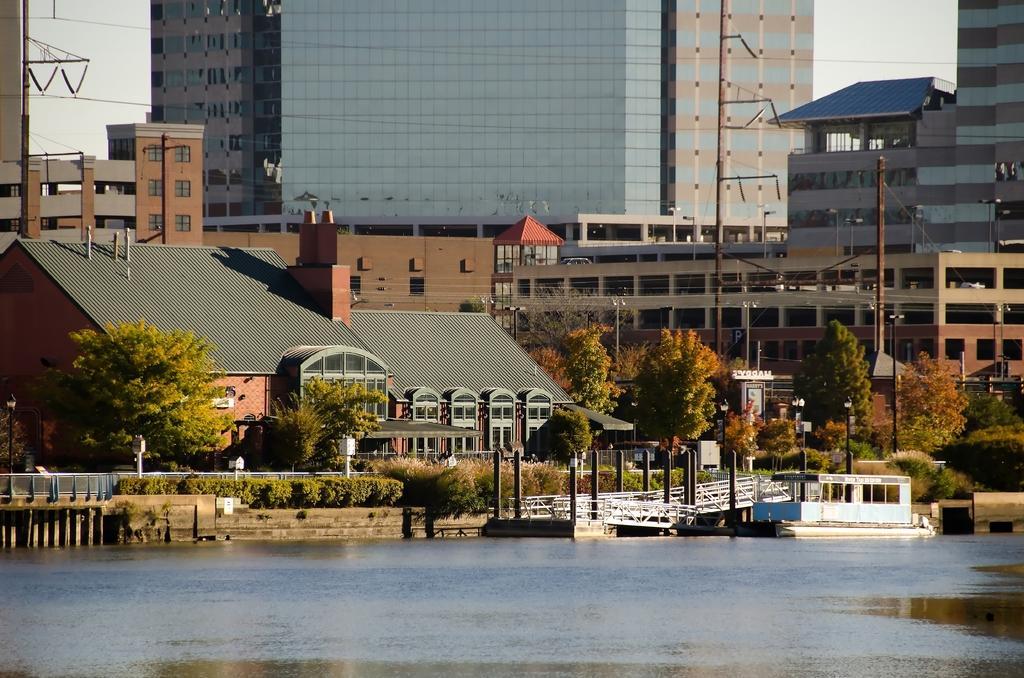Can you describe this image briefly? In the foreground I can see water, fence, plants, pillars, bridge, light poles and trees. In the background I can see buildings, wires, windows, boards and the sky. This image is taken may be during a day. 